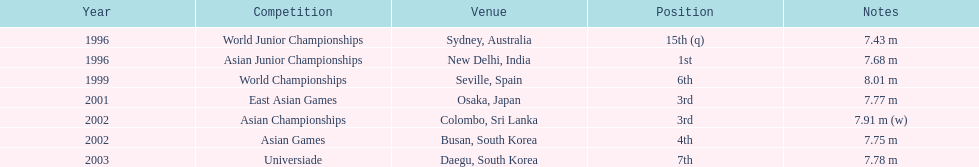How many more times was the third position achieved compared to the first position? 1. 